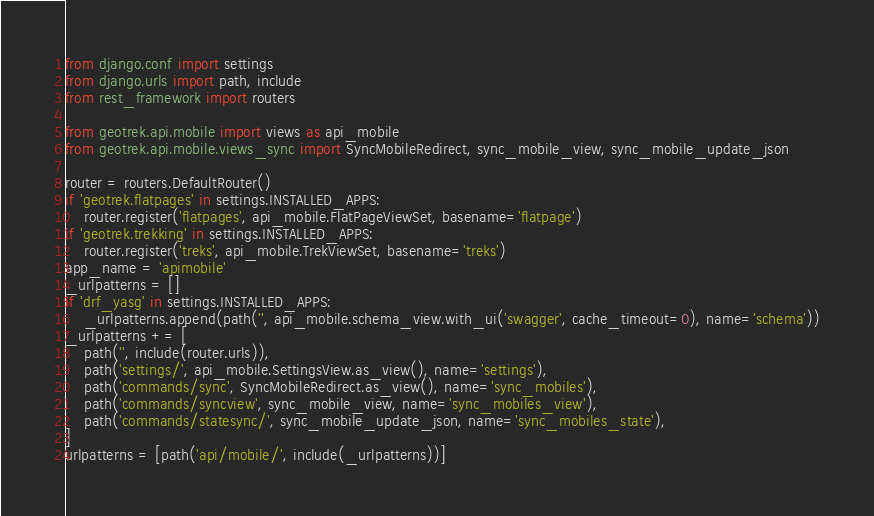<code> <loc_0><loc_0><loc_500><loc_500><_Python_>from django.conf import settings
from django.urls import path, include
from rest_framework import routers

from geotrek.api.mobile import views as api_mobile
from geotrek.api.mobile.views_sync import SyncMobileRedirect, sync_mobile_view, sync_mobile_update_json

router = routers.DefaultRouter()
if 'geotrek.flatpages' in settings.INSTALLED_APPS:
    router.register('flatpages', api_mobile.FlatPageViewSet, basename='flatpage')
if 'geotrek.trekking' in settings.INSTALLED_APPS:
    router.register('treks', api_mobile.TrekViewSet, basename='treks')
app_name = 'apimobile'
_urlpatterns = []
if 'drf_yasg' in settings.INSTALLED_APPS:
    _urlpatterns.append(path('', api_mobile.schema_view.with_ui('swagger', cache_timeout=0), name='schema'))
_urlpatterns += [
    path('', include(router.urls)),
    path('settings/', api_mobile.SettingsView.as_view(), name='settings'),
    path('commands/sync', SyncMobileRedirect.as_view(), name='sync_mobiles'),
    path('commands/syncview', sync_mobile_view, name='sync_mobiles_view'),
    path('commands/statesync/', sync_mobile_update_json, name='sync_mobiles_state'),
]
urlpatterns = [path('api/mobile/', include(_urlpatterns))]
</code> 